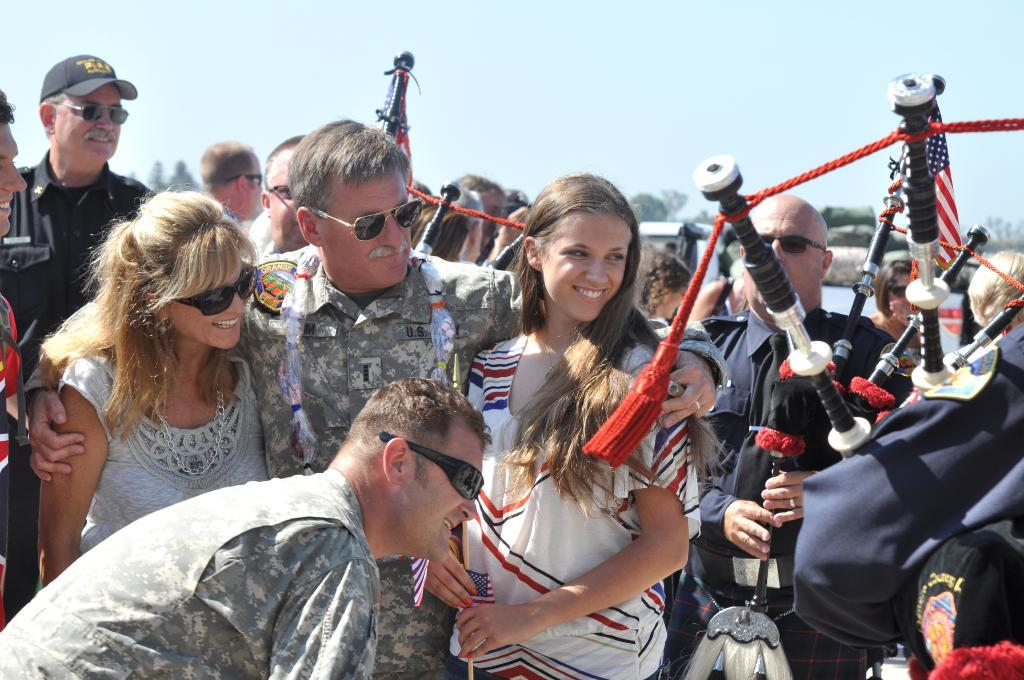How many people are in the image? There is a group of people in the image, but the exact number cannot be determined from the provided facts. What other objects are present in the image besides the people? There are other objects in the image, but their specific nature cannot be determined from the provided facts. What can be seen in the background of the image? The sky is visible in the background of the image. Where is the building located in the image? There is no building present in the image. What type of event is taking place in the image? There is no event taking place in the image; it simply features a group of people and other objects. 